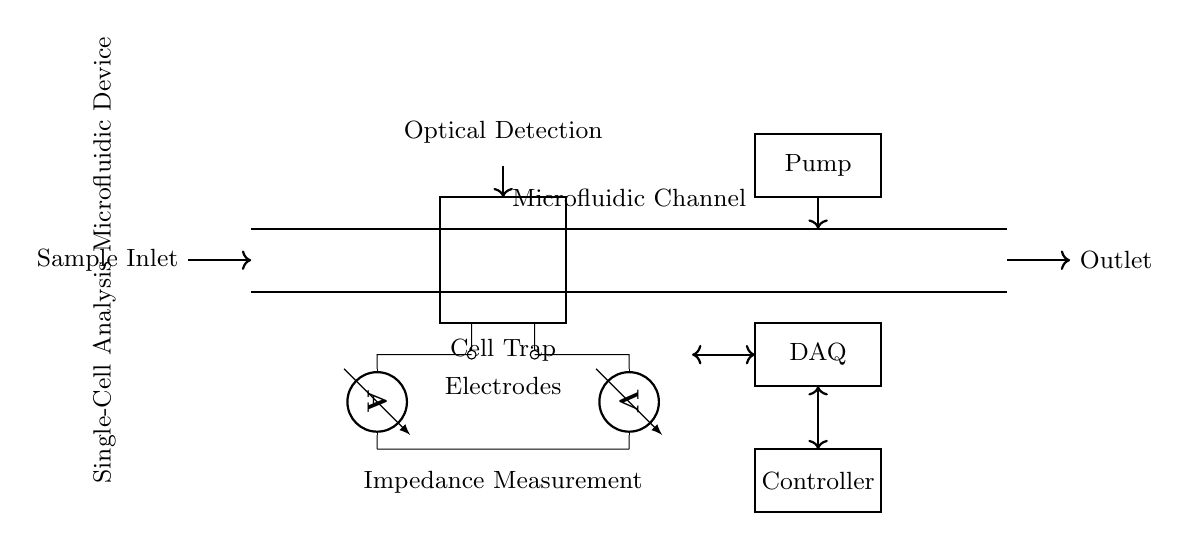What is the main function of the channel in the device? The channel is designed to transport fluid samples, enabling single-cell analysis. It connects the sample inlet to the outlet for continuous flow through the circuit.
Answer: Transport fluid samples How many electrodes are present in the circuit? Two electrodes are depicted in the diagram, located below the cell trapping region, which are used for impedance measurement.
Answer: Two What is the purpose of the pump in the circuit? The pump is responsible for controlling the flow of fluid through the microfluidic channel, facilitating the introduction and movement of samples.
Answer: Control fluid flow What type of measurement is indicated in the impedance measurement section? The measurement being indicated involves assessing the electrical properties of cells trapped in the channel by measuring current and voltage.
Answer: Electrical properties How is the data acquisition system connected to the circuit? The DAQ system is connected to the circuit through a bidirectional link, allowing it to both send and receive data related to the analysis of the fluid samples.
Answer: Bidirectional link What is the main role of the optical detection component? The optical detection component is used to analyze the characteristics of individual cells by utilizing light-based methods, such as fluorescence or absorbance detection.
Answer: Analyze cell characteristics 